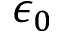Convert formula to latex. <formula><loc_0><loc_0><loc_500><loc_500>\epsilon _ { 0 }</formula> 